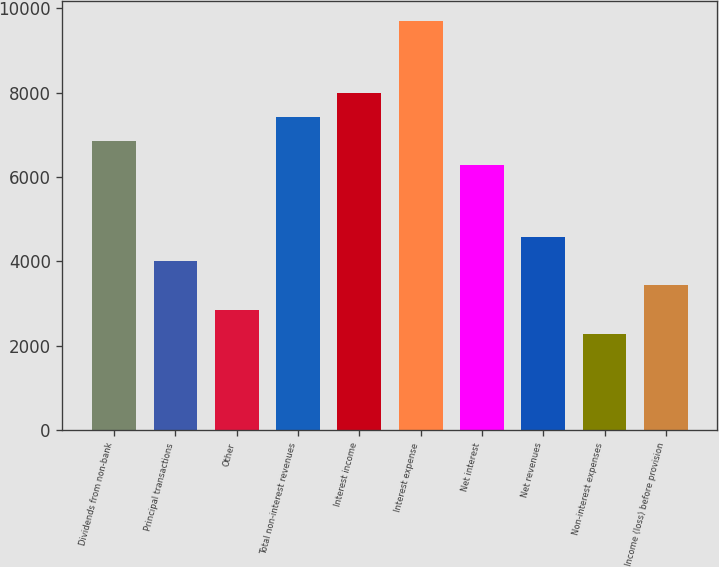Convert chart. <chart><loc_0><loc_0><loc_500><loc_500><bar_chart><fcel>Dividends from non-bank<fcel>Principal transactions<fcel>Other<fcel>Total non-interest revenues<fcel>Interest income<fcel>Interest expense<fcel>Net interest<fcel>Net revenues<fcel>Non-interest expenses<fcel>Income (loss) before provision<nl><fcel>6847.8<fcel>3998.3<fcel>2858.5<fcel>7417.7<fcel>7987.6<fcel>9697.3<fcel>6277.9<fcel>4568.2<fcel>2288.6<fcel>3428.4<nl></chart> 